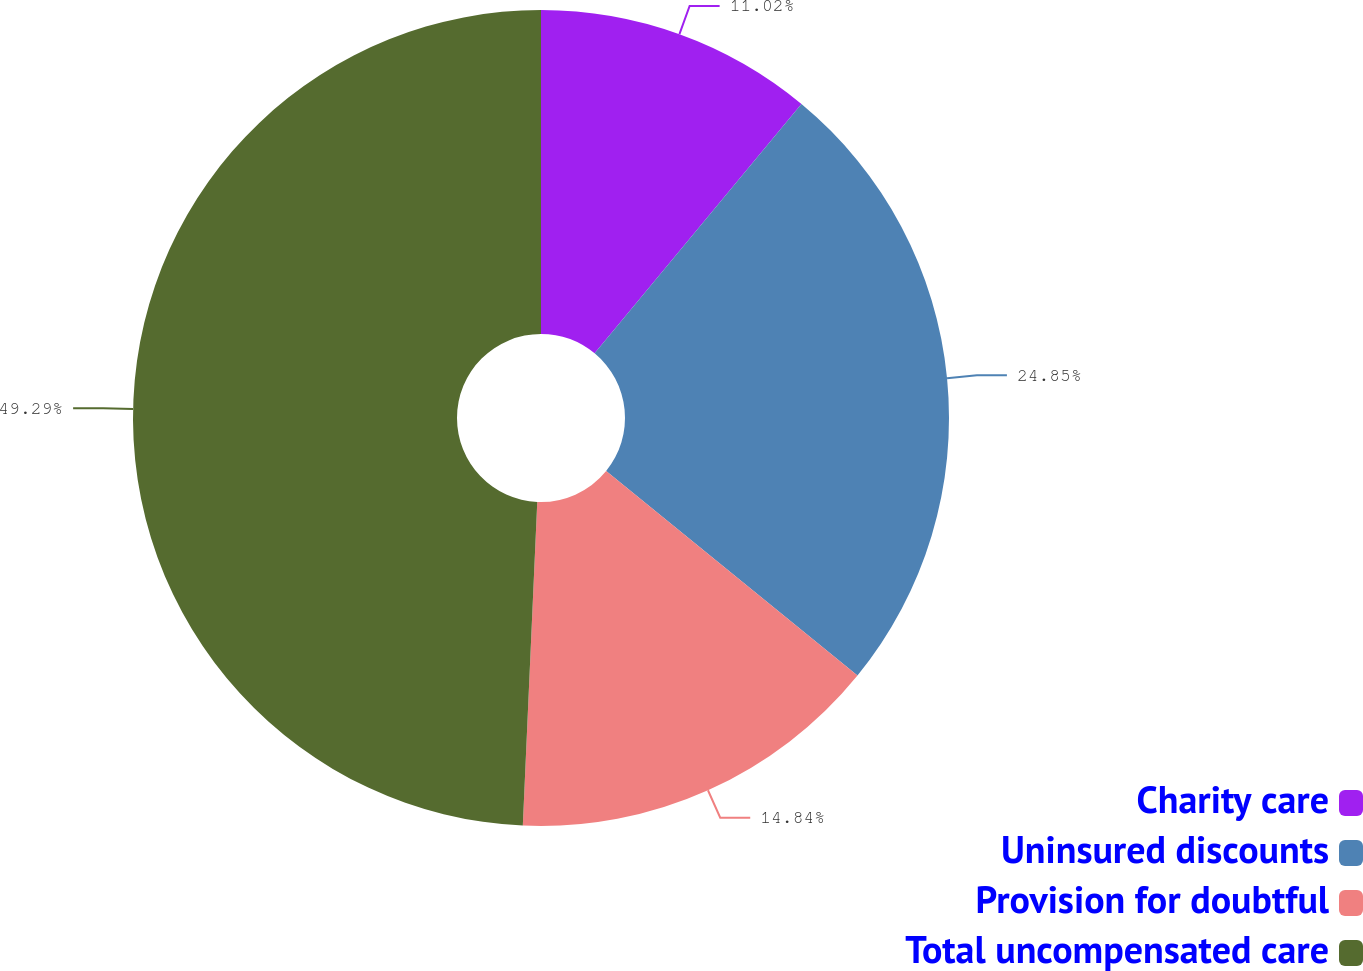Convert chart. <chart><loc_0><loc_0><loc_500><loc_500><pie_chart><fcel>Charity care<fcel>Uninsured discounts<fcel>Provision for doubtful<fcel>Total uncompensated care<nl><fcel>11.02%<fcel>24.85%<fcel>14.84%<fcel>49.29%<nl></chart> 